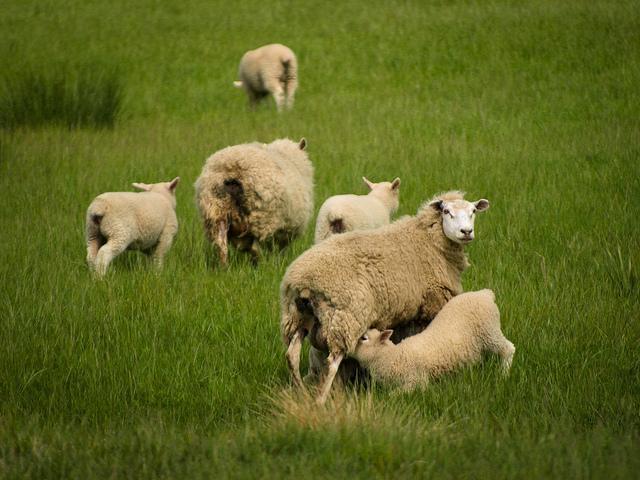What is the baby sheep doing?
Choose the right answer and clarify with the format: 'Answer: answer
Rationale: rationale.'
Options: Dancing, sleeping, eating, drinking. Answer: drinking.
Rationale: The sheep is drinking. 